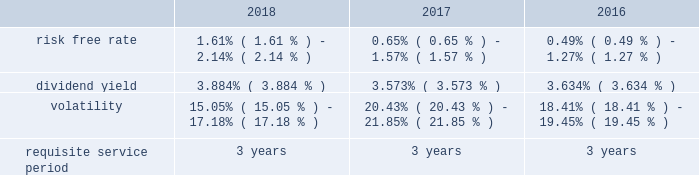Stock based compensation overview maa accounts for its stock based employee compensation plans in accordance with accounting standards governing stock based compensation .
These standards require an entity to measure the cost of employee services received in exchange for an award of an equity instrument based on the award's fair value on the grant date and recognize the cost over the period during which the employee is required to provide service in exchange for the award , which is generally the vesting period .
Any liability awards issued are remeasured at each reporting period .
Maa 2019s stock compensation plans consist of a number of incentives provided to attract and retain independent directors , executive officers and key employees .
Incentives are currently granted under the second amended and restated 2013 stock incentive plan , or the stock plan , which was approved at the 2018 annual meeting of maa shareholders .
The stock plan allows for the grant of restricted stock and stock options up to 2000000 shares .
Maa believes that such awards better align the interests of its employees with those of its shareholders .
Compensation expense is generally recognized for service based restricted stock awards using the straight-line method over the vesting period of the shares regardless of cliff or ratable vesting distinctions .
Compensation expense for market and performance based restricted stock awards is generally recognized using the accelerated amortization method with each vesting tranche valued as a separate award , with a separate vesting date , consistent with the estimated value of the award at each period end .
Additionally , compensation expense is adjusted for actual forfeitures for all awards in the period that the award was forfeited .
Compensation expense for stock options is generally recognized on a straight-line basis over the requisite service period .
Maa presents stock compensation expense in the consolidated statements of operations in "general and administrative expenses" .
Total compensation expense under the stock plan was $ 12.9 million , $ 10.8 million and $ 12.2 million for the years ended december 31 , 2018 , 2017 and 2016 , respectively .
Of these amounts , total compensation expense capitalized was $ 0.5 million , $ 0.2 million and $ 0.7 million for the years ended december 31 , 2018 , 2017 and 2016 , respectively .
As of december 31 , 2018 , the total unrecognized compensation expense was $ 13.5 million .
This cost is expected to be recognized over the remaining weighted average period of 1.1 years .
Total cash paid for the settlement of plan shares totaled $ 2.9 million , $ 4.8 million and $ 2.0 million for the years ended december 31 , 2018 , 2017 and 2016 , respectively .
Information concerning grants under the stock plan is provided below .
Restricted stock in general , restricted stock is earned based on either a service condition , performance condition , or market condition , or a combination thereof , and generally vests ratably over a period from 1 year to 5 years .
Service based awards are earned when the employee remains employed over the requisite service period and are valued on the grant date based upon the market price of maa common stock on the date of grant .
Market based awards are earned when maa reaches a specified stock price or specified return on the stock price ( price appreciation plus dividends ) and are valued on the grant date using a monte carlo simulation .
Performance based awards are earned when maa reaches certain operational goals such as funds from operations , or ffo , targets and are valued based upon the market price of maa common stock on the date of grant as well as the probability of reaching the stated targets .
Maa remeasures the fair value of the performance based awards each balance sheet date with adjustments made on a cumulative basis until the award is settled and the final compensation is known .
The weighted average grant date fair value per share of restricted stock awards granted during the years ended december 31 , 2018 , 2017 and 2016 , was $ 71.85 , $ 84.53 and $ 73.20 , respectively .
The following is a summary of the key assumptions used in the valuation calculations for market based awards granted during the years ended december 31 , 2018 , 2017 and 2016: .
The risk free rate was based on a zero coupon risk-free rate .
The minimum risk free rate was based on a period of 0.25 years for the years ended december 31 , 2018 , 2017 and 2016 .
The maximum risk free rate was based on a period of 3 years for the years ended december 31 , 2018 , 2017 and 2016 .
The dividend yield was based on the closing stock price of maa stock on the .
What was the percent of the change in the weighted average grant date fair value per share of restricted stock awards granted from 2016 to 2017? 
Rationale: the weighted average grant date fair value per share of restricted stock awards granted increased by 15.5% from 2016 to 2017
Computations: ((84.53 - 73.20) / 73.20)
Answer: 0.15478. 